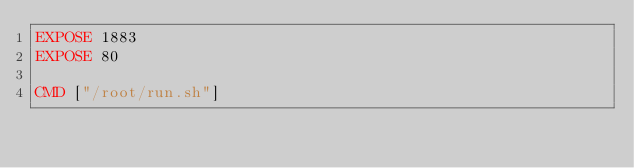<code> <loc_0><loc_0><loc_500><loc_500><_Dockerfile_>EXPOSE 1883
EXPOSE 80

CMD ["/root/run.sh"]
</code> 